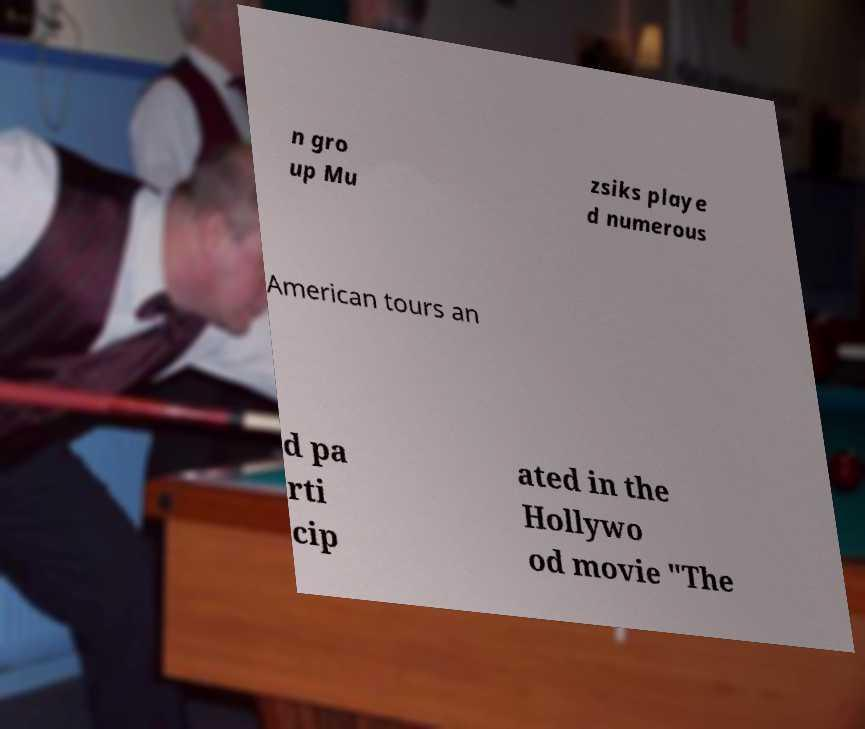Can you accurately transcribe the text from the provided image for me? n gro up Mu zsiks playe d numerous American tours an d pa rti cip ated in the Hollywo od movie "The 